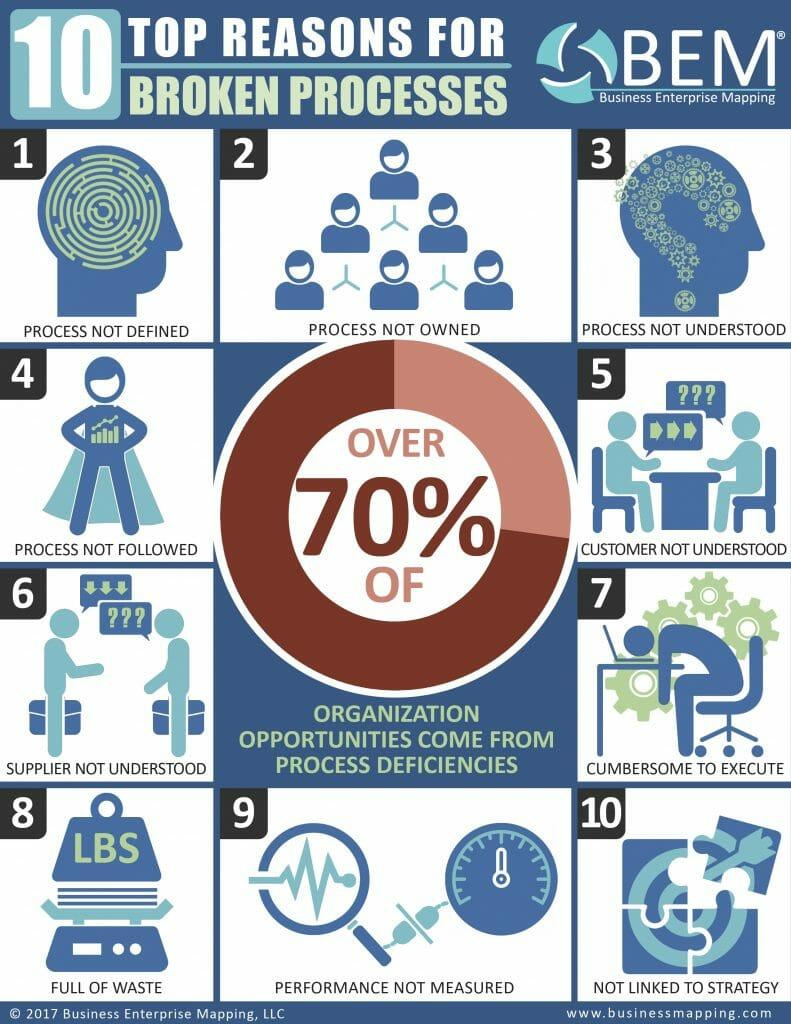Mention a couple of crucial points in this snapshot. The message "Process not understood" is a declaration stating that the current process is unknown or undefined. Of the processes that have been broken due to a lack of understanding, approximately 3 of them have been affected. 